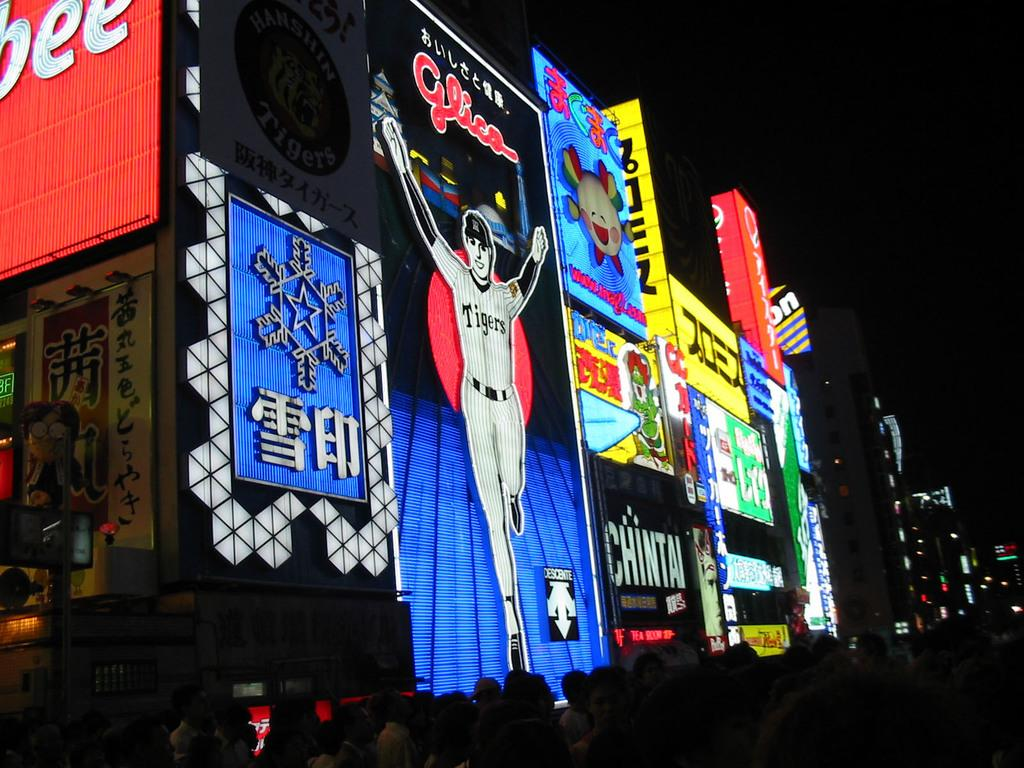What type of structures can be seen in the image? There are buildings in the image. What else is visible in the image besides the buildings? There are lights and colorful boards in the image. Are there any living beings present in the image? Yes, there are people in the image. How would you describe the overall lighting in the image? The image is dark. What type of can is being used by the people in the image? There is no can present in the image; it only features buildings, lights, colorful boards, and people. How does the whistle sound in the image? There is no whistle present in the image, so it is not possible to determine its sound. 